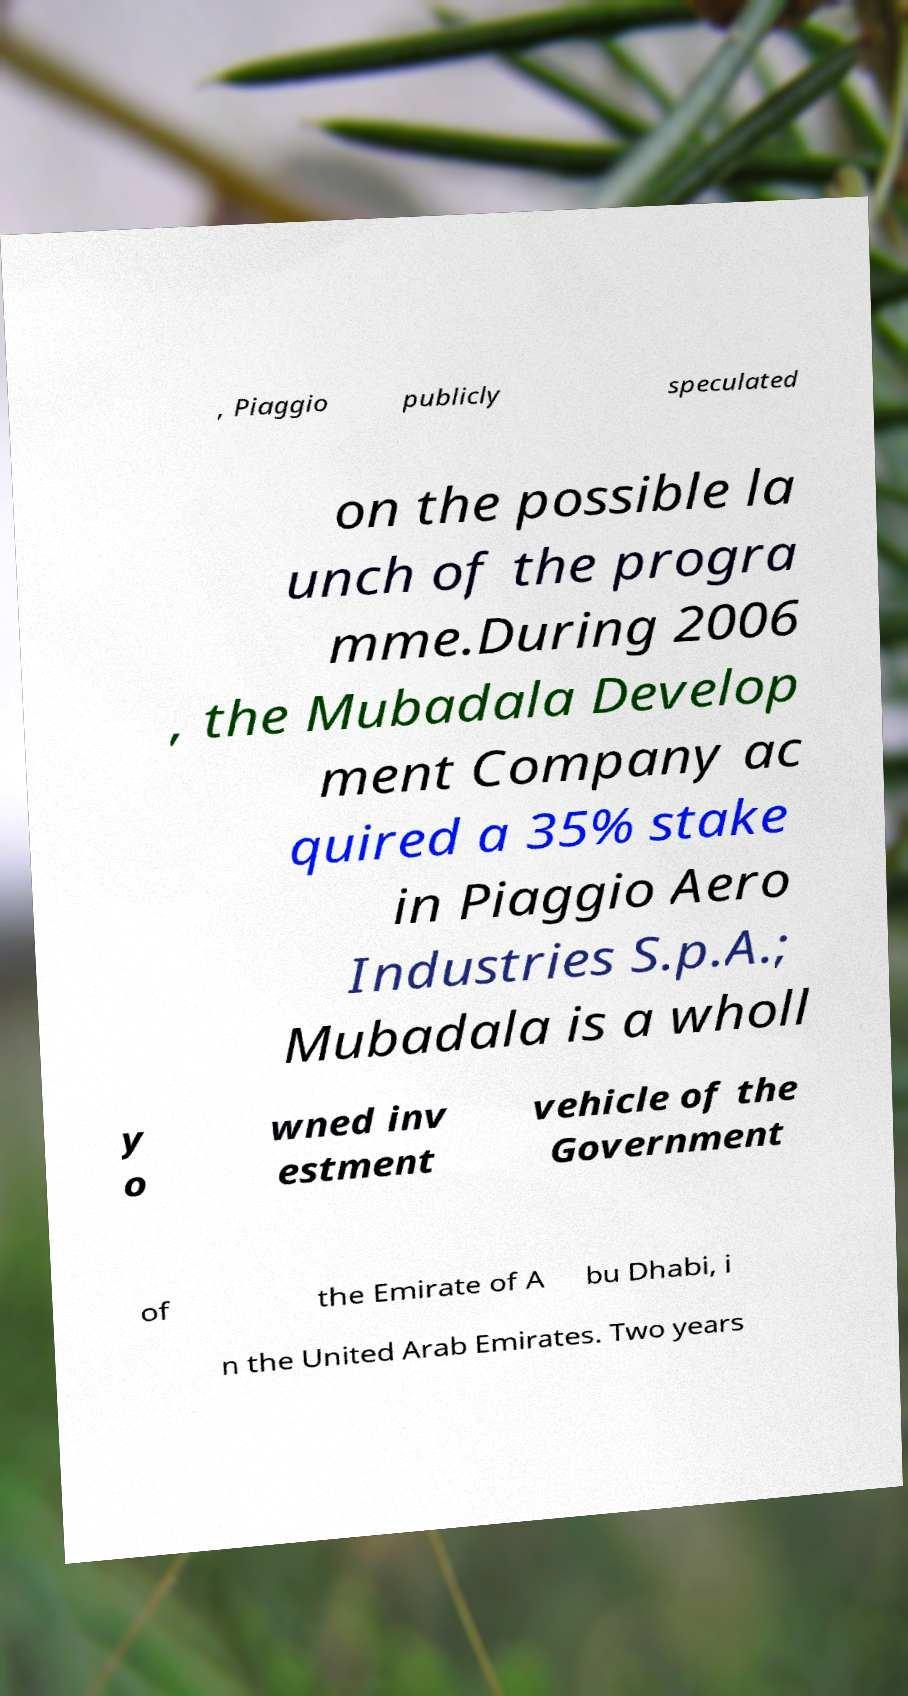There's text embedded in this image that I need extracted. Can you transcribe it verbatim? , Piaggio publicly speculated on the possible la unch of the progra mme.During 2006 , the Mubadala Develop ment Company ac quired a 35% stake in Piaggio Aero Industries S.p.A.; Mubadala is a wholl y o wned inv estment vehicle of the Government of the Emirate of A bu Dhabi, i n the United Arab Emirates. Two years 